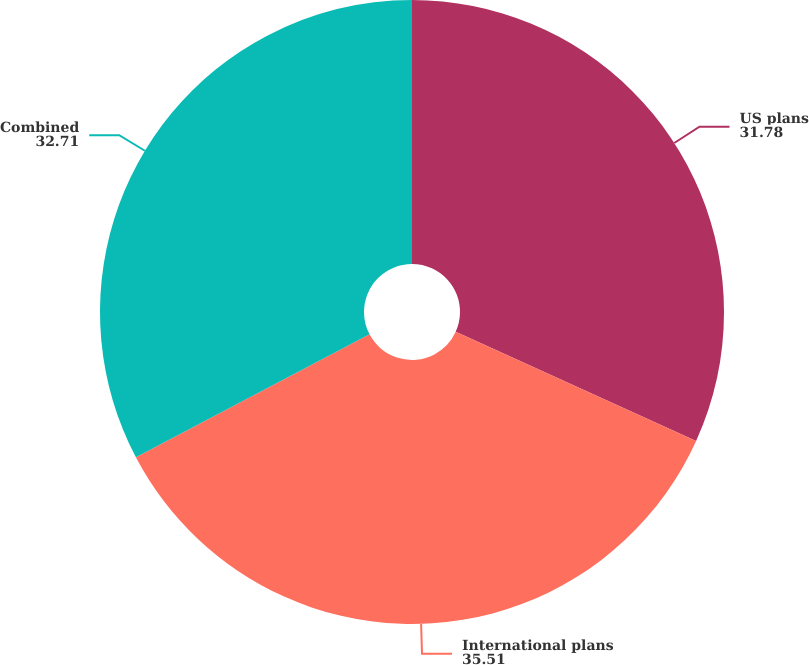Convert chart to OTSL. <chart><loc_0><loc_0><loc_500><loc_500><pie_chart><fcel>US plans<fcel>International plans<fcel>Combined<nl><fcel>31.78%<fcel>35.51%<fcel>32.71%<nl></chart> 